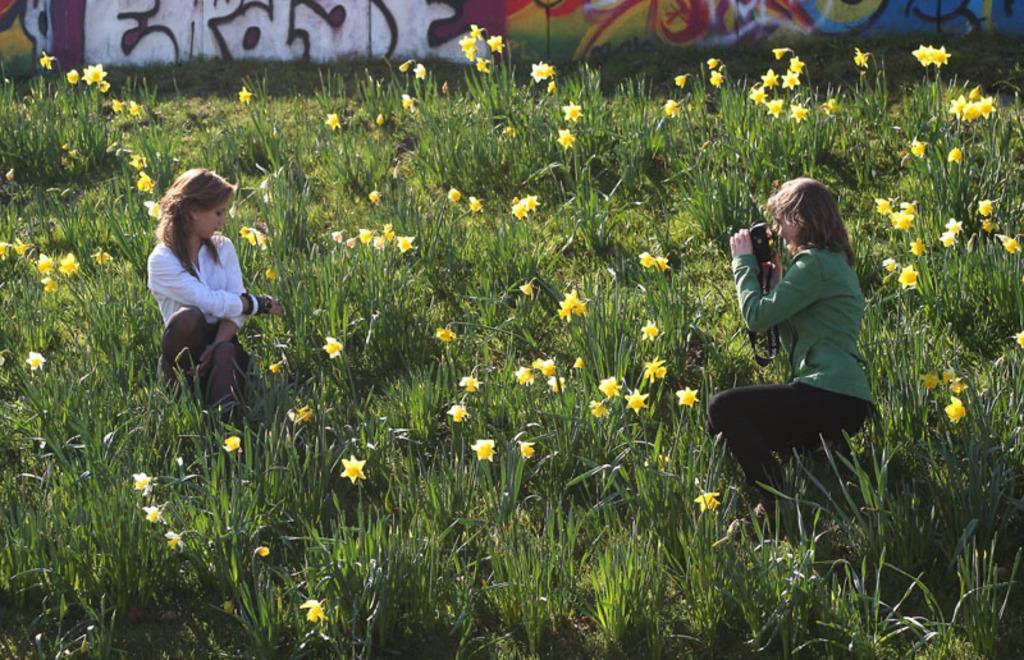In one or two sentences, can you explain what this image depicts? In the image there is a flower garden and a woman is sitting and posing for the photo and another woman is capturing her with the camera, in the background there is a wall and on the wall there are some paintings. 